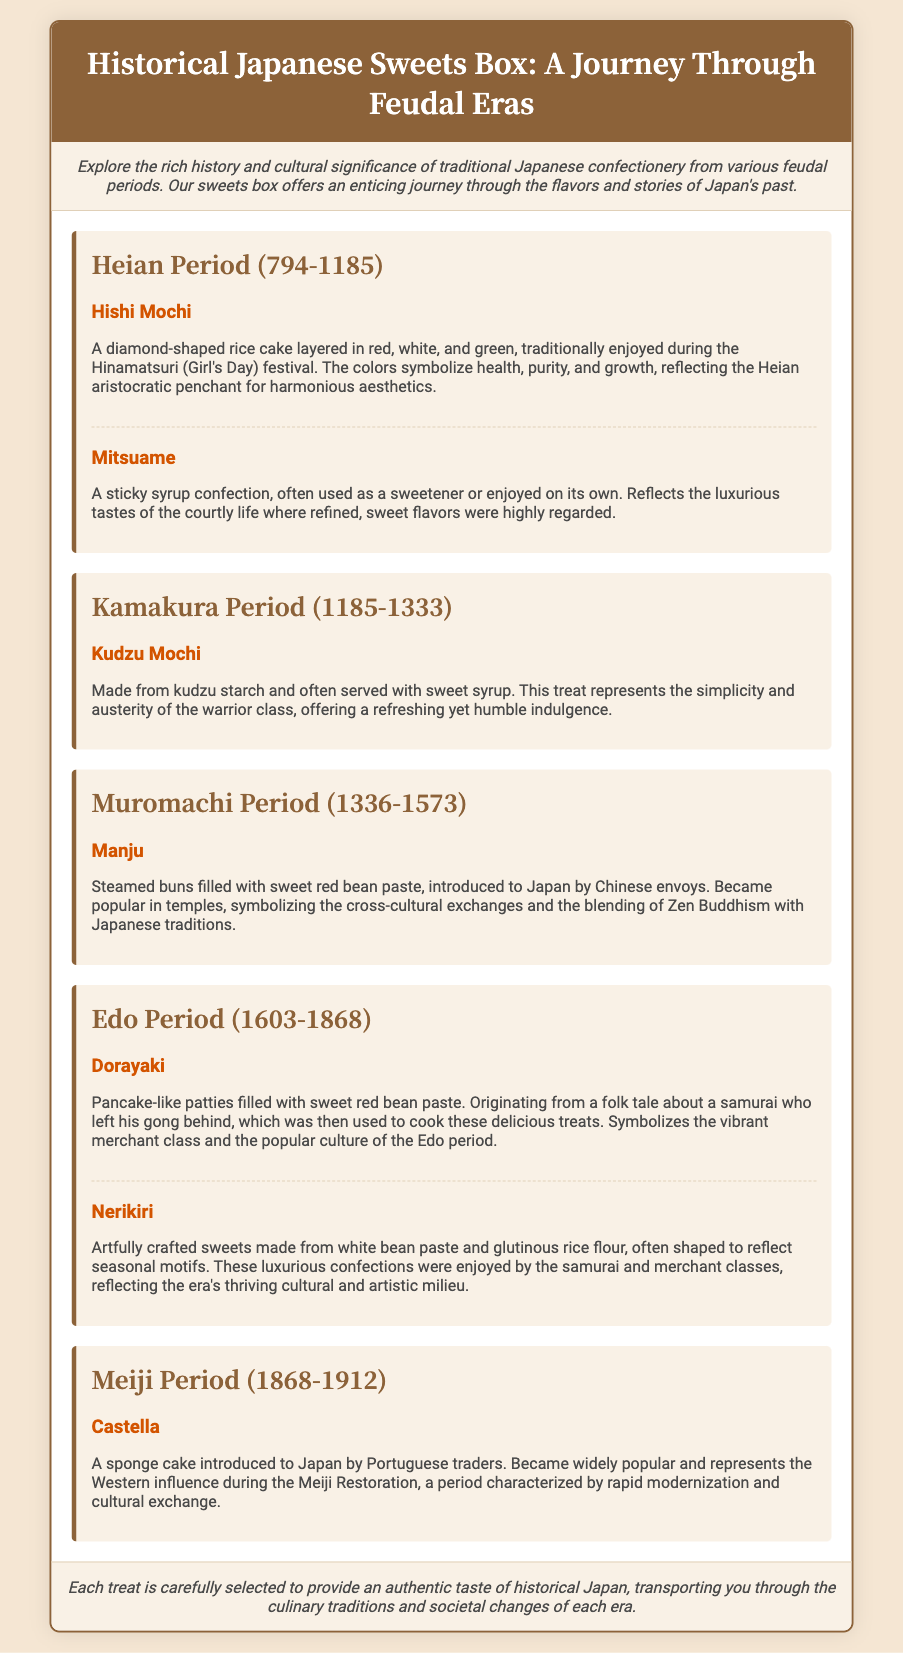What sweets are included from the Heian Period? The document lists Hishi Mochi and Mitsuame as treats from the Heian Period.
Answer: Hishi Mochi, Mitsuame What does the Hishi Mochi symbolize? The colors of Hishi Mochi symbolize health, purity, and growth, reflecting the Heian aristocratic penchant for harmonious aesthetics.
Answer: Health, purity, growth Which period introduced Manju to Japan? Manju was introduced to Japan during the Muromachi Period by Chinese envoys.
Answer: Muromachi Period What is the main ingredient of Kudzu Mochi? Kudzu Mochi is made from kudzu starch.
Answer: Kudzu starch How many sweets are described from the Edo Period? There are two sweets described from the Edo Period: Dorayaki and Nerikiri.
Answer: Two Which treat represents Western influence during the Meiji Restoration? Castella represents Western influence during the Meiji Restoration.
Answer: Castella What characteristic does Nerikiri have? Nerikiri is artfully crafted and shaped to reflect seasonal motifs.
Answer: Shaped to reflect seasonal motifs What is the main theme of the document? The document's theme revolves around traditional Japanese confectionery and their historical and cultural significance.
Answer: Cultural significance 